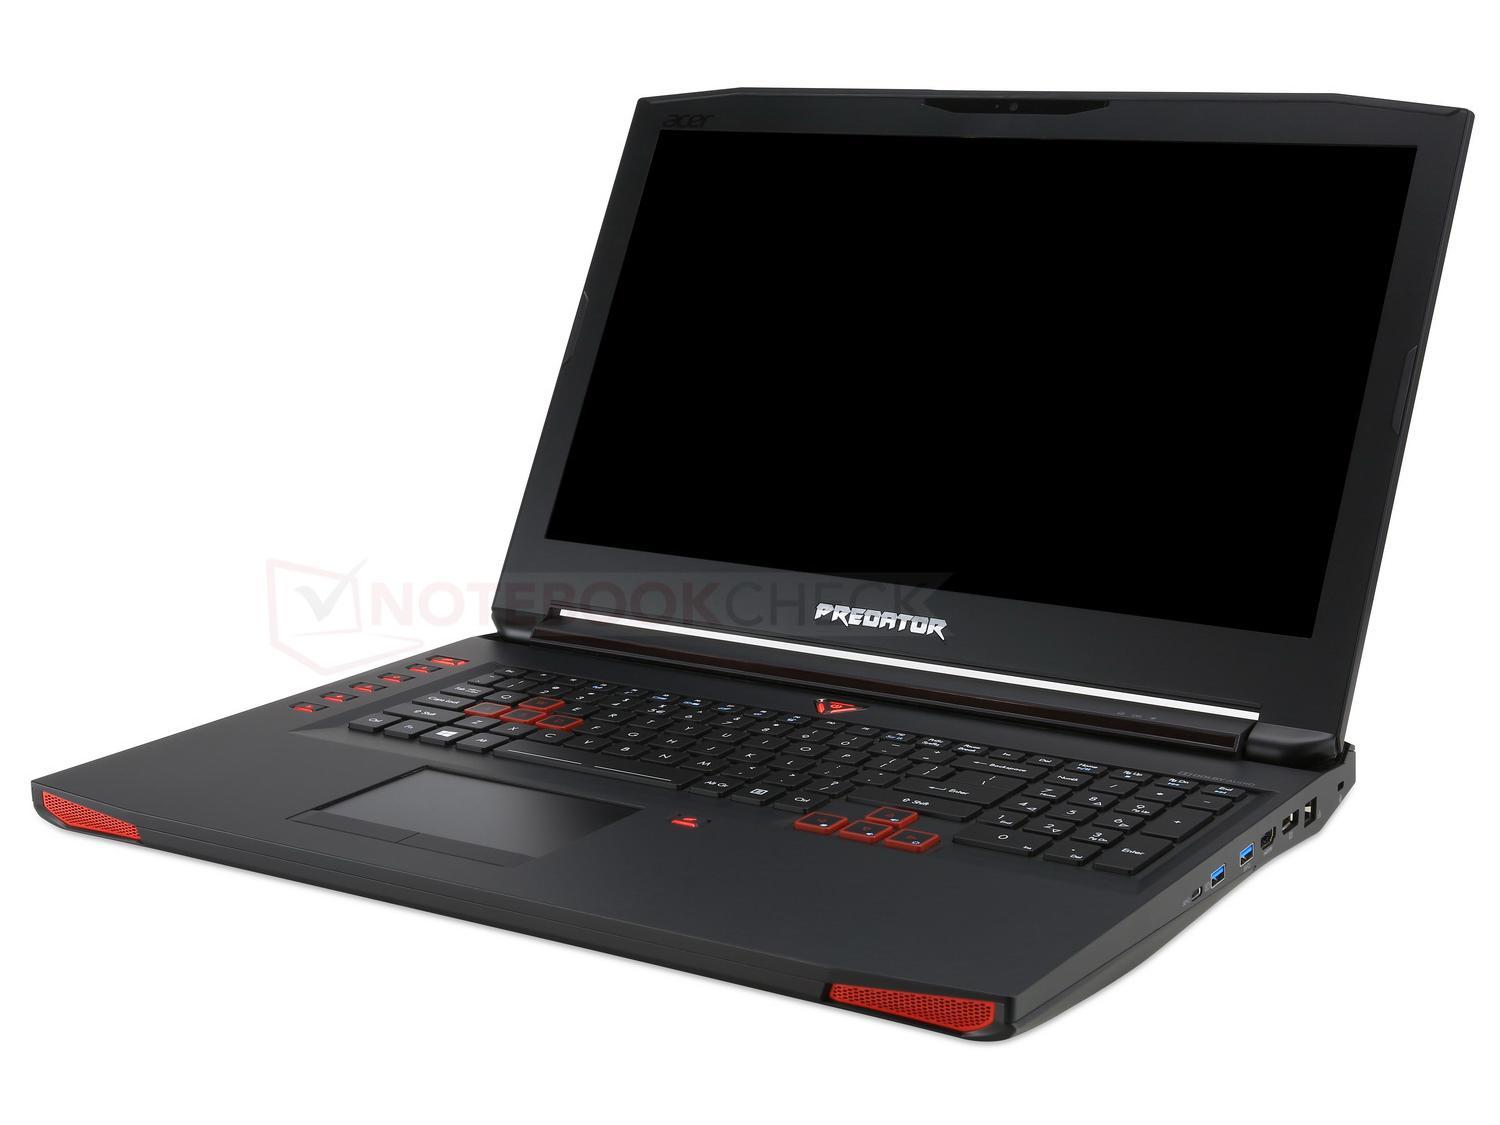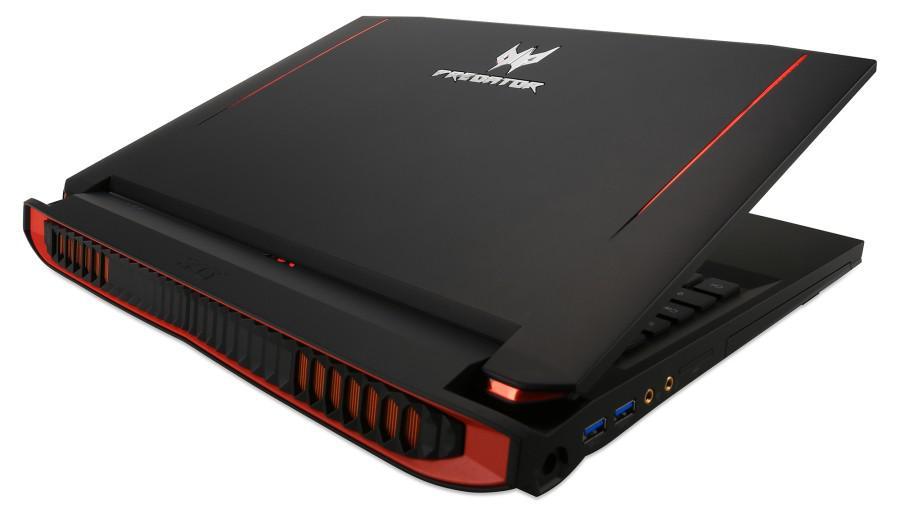The first image is the image on the left, the second image is the image on the right. Given the left and right images, does the statement "The laptop on the left is opened to at least 90-degrees and has its screen facing somewhat forward, and the laptop on the right is open to about 45-degrees or less and has its back to the camera." hold true? Answer yes or no. Yes. The first image is the image on the left, the second image is the image on the right. Assess this claim about the two images: "The computer in the image on the right is angled so that the screen isn't visible.". Correct or not? Answer yes or no. Yes. 